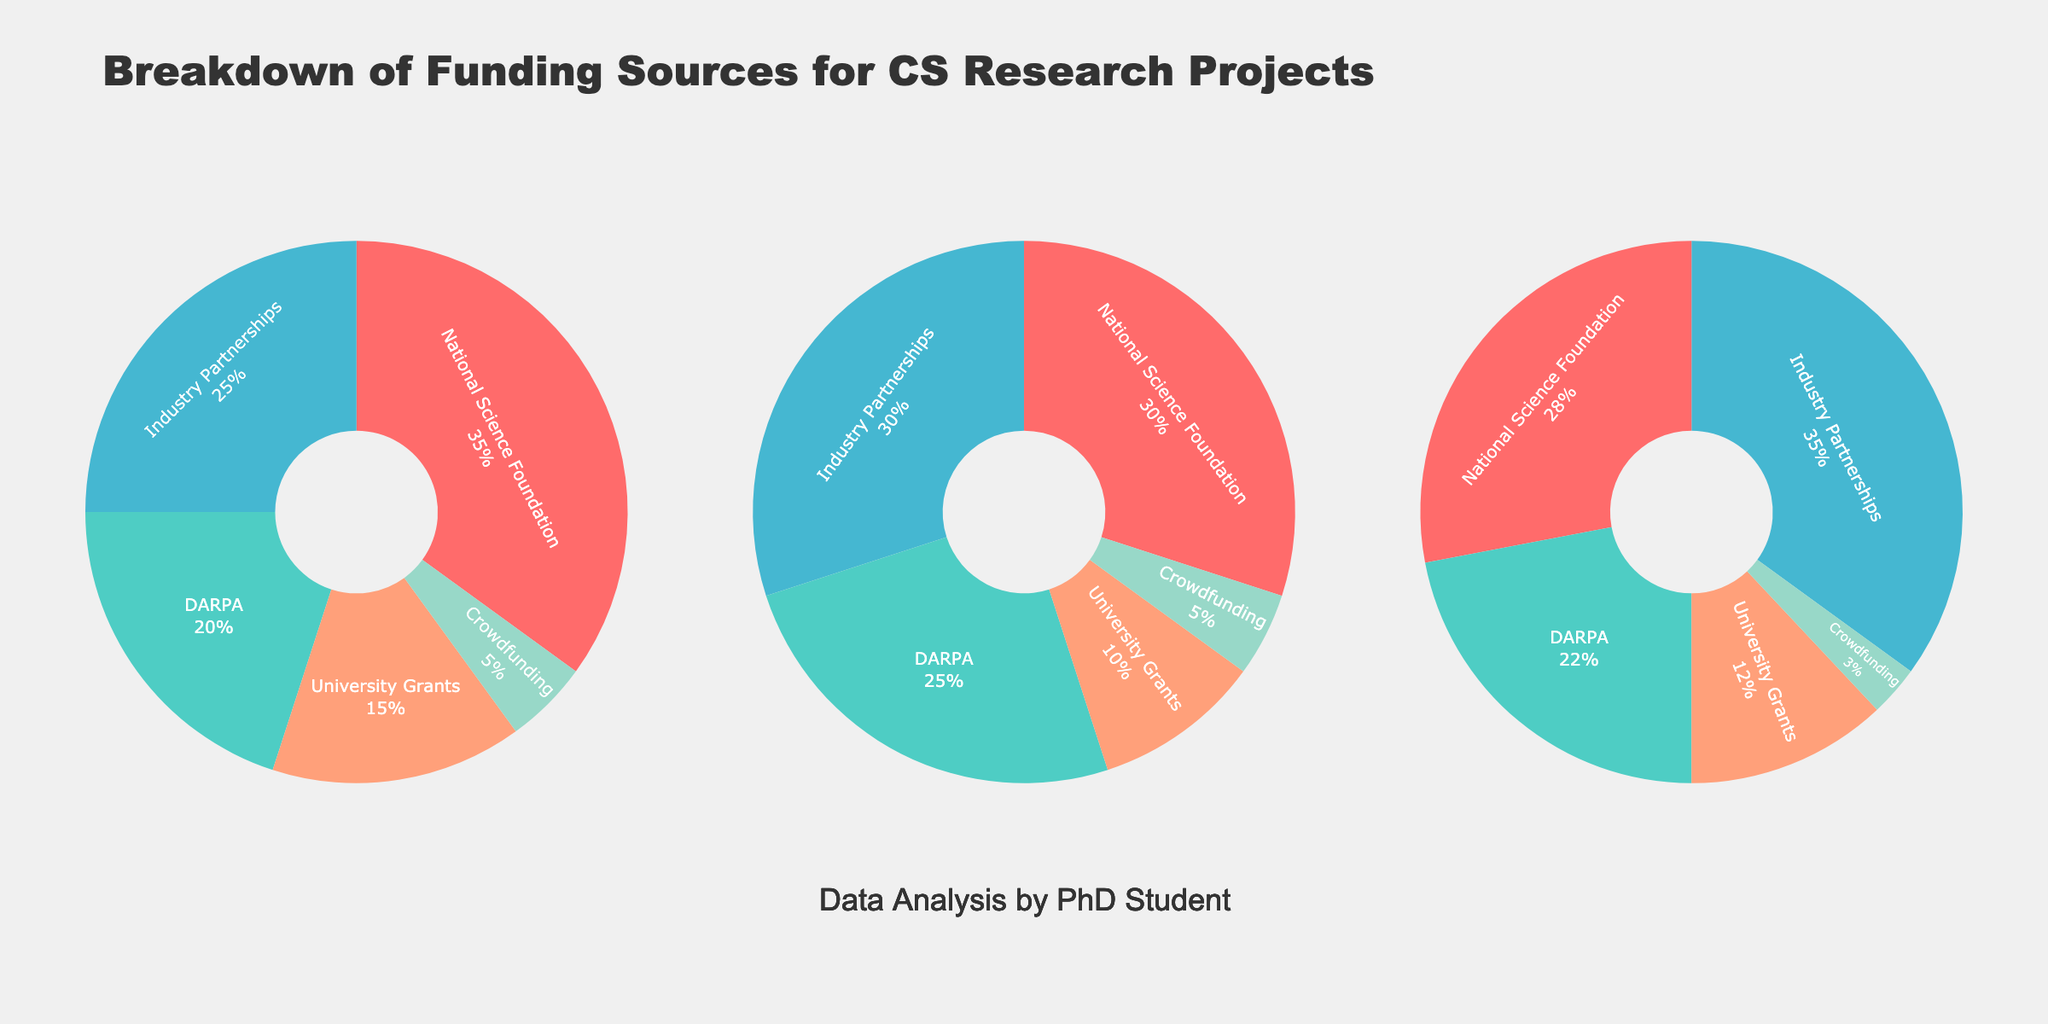What is the title of the figure? The title is located at the top center of the figure. It serves as a brief description of the content depicted in the pie charts.
Answer: Breakdown of Funding Sources for CS Research Projects Which funding source had the highest percentage in 2022? Look at the pie chart for the year 2022 and identify the funding source with the largest section.
Answer: Industry Partnerships How did the percentage of NSF funding change from 2020 to 2021? Compare the NSF percentage values between the pie charts for 2020 and 2021. Subtract the 2021 value from the 2020 value to find the change.
Answer: Decreased by 5% What was the total percentage of external funding sources (NSF + DARPA + Industry Partnerships) in 2021? Sum the percentages of NSF, DARPA, and Industry Partnerships for the 2021 pie chart.
Answer: 85% Which year had the highest percentage of crowdfunding? Identify the crowdfunding section in each pie chart and compare the percentages.
Answer: 2020 Did the percentage of university grants increase or decrease from 2020 to 2022? Compare the university grants percentages in the pie charts for 2020 and 2022. If the 2022 value is higher, it increased; otherwise, it decreased.
Answer: Decreased What is the difference in the percentage of industry partnerships between 2020 and 2022? Subtract the industry partnerships percentage in 2020 from the percentage in 2022.
Answer: 10% Which funding source had consistently the lowest percentage across all years? Identify the segment representing each funding source in all pie charts and compare. The consistently lowest one is the answer.
Answer: Crowdfunding What is the average percentage of DARPA funding across the three years? Add the DARPA percentages for 2020, 2021, and 2022, then divide by 3 to find the average.
Answer: 22.33% How did the overall composition of funding sources change from 2020 to 2022? Analyze the pie charts for 2020 and 2022 and describe the main changes in the proportion of each funding source. Look for increases or decreases in each segment.
Answer: NSF decreased, DARPA decreased slightly, Industry Partnerships increased, University Grants slightly decreased, Crowdfunding decreased 